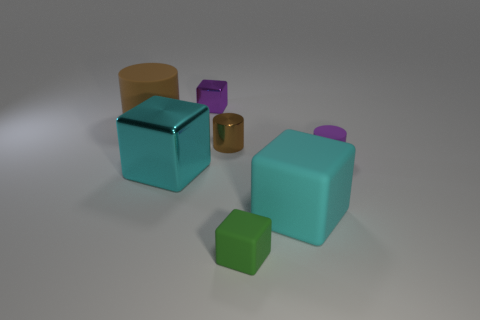Add 1 small purple cubes. How many objects exist? 8 Subtract all blocks. How many objects are left? 3 Subtract 0 yellow spheres. How many objects are left? 7 Subtract all small green blocks. Subtract all tiny purple things. How many objects are left? 4 Add 3 big blocks. How many big blocks are left? 5 Add 5 small purple matte cylinders. How many small purple matte cylinders exist? 6 